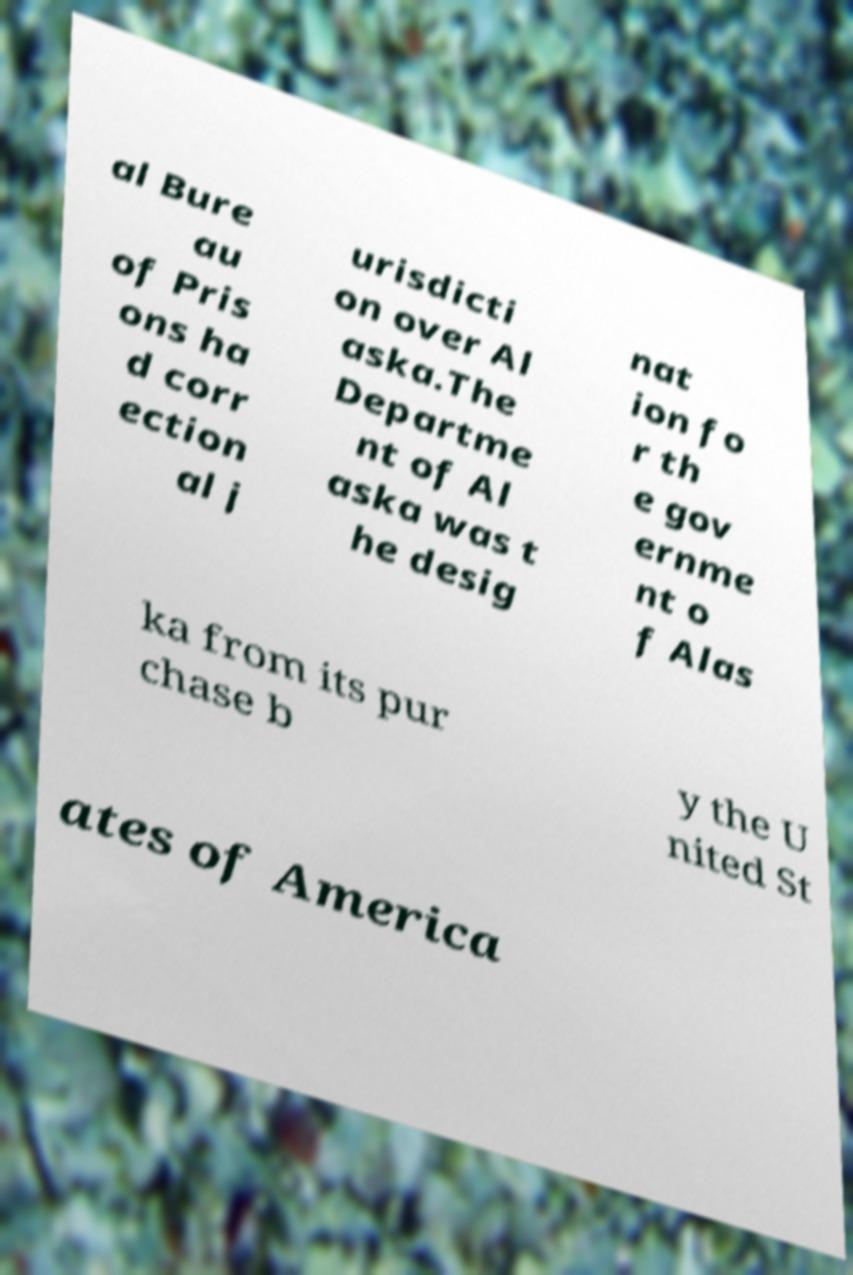Please identify and transcribe the text found in this image. al Bure au of Pris ons ha d corr ection al j urisdicti on over Al aska.The Departme nt of Al aska was t he desig nat ion fo r th e gov ernme nt o f Alas ka from its pur chase b y the U nited St ates of America 